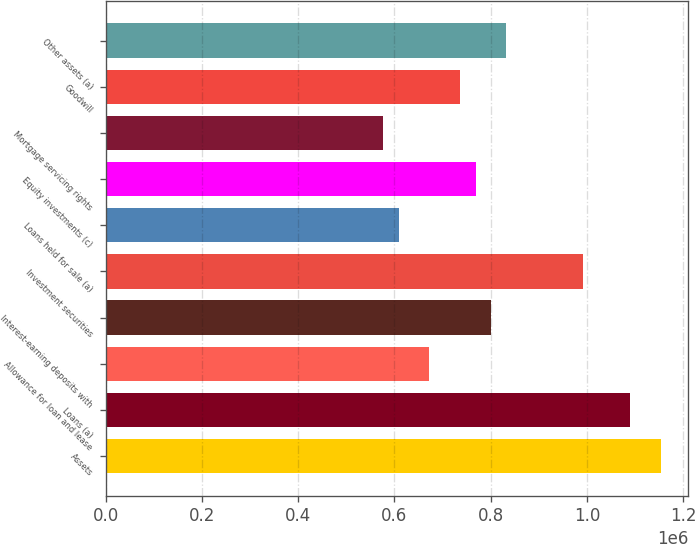Convert chart. <chart><loc_0><loc_0><loc_500><loc_500><bar_chart><fcel>Assets<fcel>Loans (a)<fcel>Allowance for loan and lease<fcel>Interest-earning deposits with<fcel>Investment securities<fcel>Loans held for sale (a)<fcel>Equity investments (c)<fcel>Mortgage servicing rights<fcel>Goodwill<fcel>Other assets (a)<nl><fcel>1.15269e+06<fcel>1.08865e+06<fcel>672402<fcel>800478<fcel>992592<fcel>608364<fcel>768459<fcel>576344<fcel>736440<fcel>832497<nl></chart> 